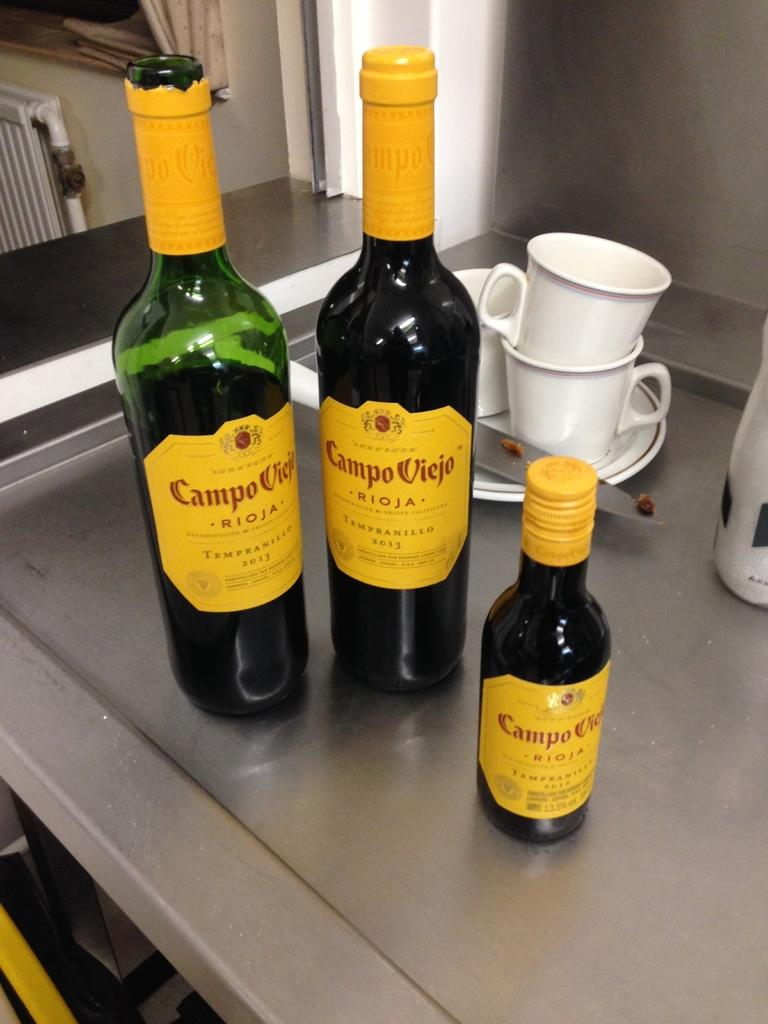<image>
Present a compact description of the photo's key features. Bottles of Campo Viejo next to some white cups. 